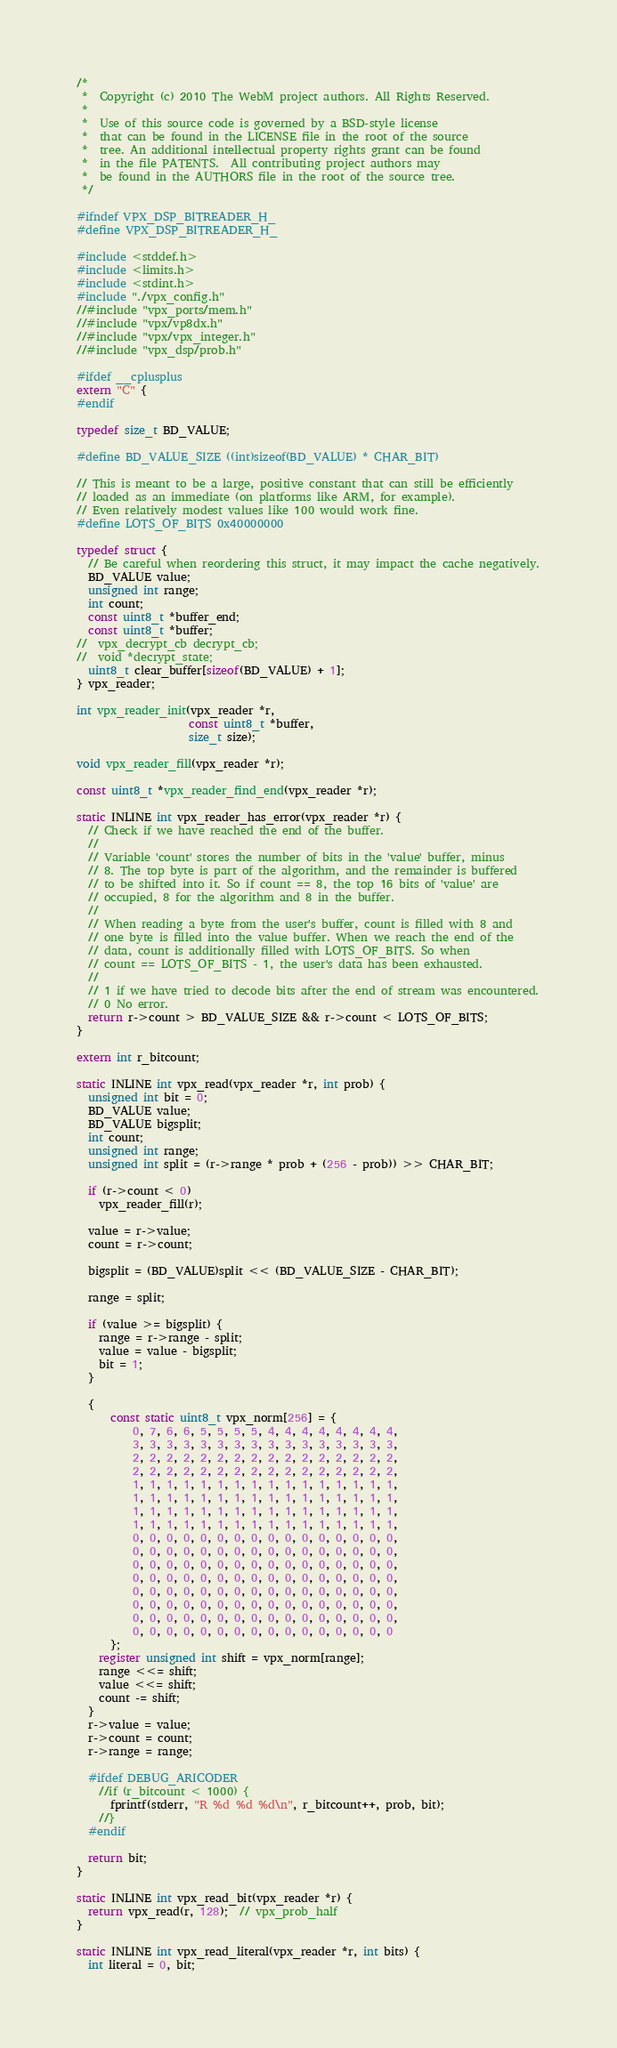Convert code to text. <code><loc_0><loc_0><loc_500><loc_500><_C_>/*
 *  Copyright (c) 2010 The WebM project authors. All Rights Reserved.
 *
 *  Use of this source code is governed by a BSD-style license
 *  that can be found in the LICENSE file in the root of the source
 *  tree. An additional intellectual property rights grant can be found
 *  in the file PATENTS.  All contributing project authors may
 *  be found in the AUTHORS file in the root of the source tree.
 */

#ifndef VPX_DSP_BITREADER_H_
#define VPX_DSP_BITREADER_H_

#include <stddef.h>
#include <limits.h>
#include <stdint.h>
#include "./vpx_config.h"
//#include "vpx_ports/mem.h"
//#include "vpx/vp8dx.h"
//#include "vpx/vpx_integer.h"
//#include "vpx_dsp/prob.h"

#ifdef __cplusplus
extern "C" {
#endif

typedef size_t BD_VALUE;

#define BD_VALUE_SIZE ((int)sizeof(BD_VALUE) * CHAR_BIT)

// This is meant to be a large, positive constant that can still be efficiently
// loaded as an immediate (on platforms like ARM, for example).
// Even relatively modest values like 100 would work fine.
#define LOTS_OF_BITS 0x40000000

typedef struct {
  // Be careful when reordering this struct, it may impact the cache negatively.
  BD_VALUE value;
  unsigned int range;
  int count;
  const uint8_t *buffer_end;
  const uint8_t *buffer;
//  vpx_decrypt_cb decrypt_cb;
//  void *decrypt_state;
  uint8_t clear_buffer[sizeof(BD_VALUE) + 1];
} vpx_reader;

int vpx_reader_init(vpx_reader *r,
                    const uint8_t *buffer,
                    size_t size);

void vpx_reader_fill(vpx_reader *r);

const uint8_t *vpx_reader_find_end(vpx_reader *r);

static INLINE int vpx_reader_has_error(vpx_reader *r) {
  // Check if we have reached the end of the buffer.
  //
  // Variable 'count' stores the number of bits in the 'value' buffer, minus
  // 8. The top byte is part of the algorithm, and the remainder is buffered
  // to be shifted into it. So if count == 8, the top 16 bits of 'value' are
  // occupied, 8 for the algorithm and 8 in the buffer.
  //
  // When reading a byte from the user's buffer, count is filled with 8 and
  // one byte is filled into the value buffer. When we reach the end of the
  // data, count is additionally filled with LOTS_OF_BITS. So when
  // count == LOTS_OF_BITS - 1, the user's data has been exhausted.
  //
  // 1 if we have tried to decode bits after the end of stream was encountered.
  // 0 No error.
  return r->count > BD_VALUE_SIZE && r->count < LOTS_OF_BITS;
}

extern int r_bitcount;

static INLINE int vpx_read(vpx_reader *r, int prob) {
  unsigned int bit = 0;
  BD_VALUE value;
  BD_VALUE bigsplit;
  int count;
  unsigned int range;
  unsigned int split = (r->range * prob + (256 - prob)) >> CHAR_BIT;

  if (r->count < 0)
    vpx_reader_fill(r);

  value = r->value;
  count = r->count;

  bigsplit = (BD_VALUE)split << (BD_VALUE_SIZE - CHAR_BIT);

  range = split;

  if (value >= bigsplit) {
    range = r->range - split;
    value = value - bigsplit;
    bit = 1;
  }

  {
      const static uint8_t vpx_norm[256] = {
          0, 7, 6, 6, 5, 5, 5, 5, 4, 4, 4, 4, 4, 4, 4, 4,
          3, 3, 3, 3, 3, 3, 3, 3, 3, 3, 3, 3, 3, 3, 3, 3,
          2, 2, 2, 2, 2, 2, 2, 2, 2, 2, 2, 2, 2, 2, 2, 2,
          2, 2, 2, 2, 2, 2, 2, 2, 2, 2, 2, 2, 2, 2, 2, 2,
          1, 1, 1, 1, 1, 1, 1, 1, 1, 1, 1, 1, 1, 1, 1, 1,
          1, 1, 1, 1, 1, 1, 1, 1, 1, 1, 1, 1, 1, 1, 1, 1,
          1, 1, 1, 1, 1, 1, 1, 1, 1, 1, 1, 1, 1, 1, 1, 1,
          1, 1, 1, 1, 1, 1, 1, 1, 1, 1, 1, 1, 1, 1, 1, 1,
          0, 0, 0, 0, 0, 0, 0, 0, 0, 0, 0, 0, 0, 0, 0, 0,
          0, 0, 0, 0, 0, 0, 0, 0, 0, 0, 0, 0, 0, 0, 0, 0,
          0, 0, 0, 0, 0, 0, 0, 0, 0, 0, 0, 0, 0, 0, 0, 0,
          0, 0, 0, 0, 0, 0, 0, 0, 0, 0, 0, 0, 0, 0, 0, 0,
          0, 0, 0, 0, 0, 0, 0, 0, 0, 0, 0, 0, 0, 0, 0, 0,
          0, 0, 0, 0, 0, 0, 0, 0, 0, 0, 0, 0, 0, 0, 0, 0,
          0, 0, 0, 0, 0, 0, 0, 0, 0, 0, 0, 0, 0, 0, 0, 0,
          0, 0, 0, 0, 0, 0, 0, 0, 0, 0, 0, 0, 0, 0, 0, 0
      };
    register unsigned int shift = vpx_norm[range];
    range <<= shift;
    value <<= shift;
    count -= shift;
  }
  r->value = value;
  r->count = count;
  r->range = range;

  #ifdef DEBUG_ARICODER
    //if (r_bitcount < 1000) {
      fprintf(stderr, "R %d %d %d\n", r_bitcount++, prob, bit);
    //}
  #endif

  return bit;
}

static INLINE int vpx_read_bit(vpx_reader *r) {
  return vpx_read(r, 128);  // vpx_prob_half
}

static INLINE int vpx_read_literal(vpx_reader *r, int bits) {
  int literal = 0, bit;
</code> 